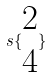<formula> <loc_0><loc_0><loc_500><loc_500>s \{ \begin{matrix} 2 \\ 4 \end{matrix} \}</formula> 